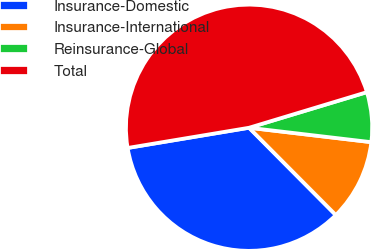Convert chart to OTSL. <chart><loc_0><loc_0><loc_500><loc_500><pie_chart><fcel>Insurance-Domestic<fcel>Insurance-International<fcel>Reinsurance-Global<fcel>Total<nl><fcel>34.83%<fcel>10.68%<fcel>6.54%<fcel>47.96%<nl></chart> 